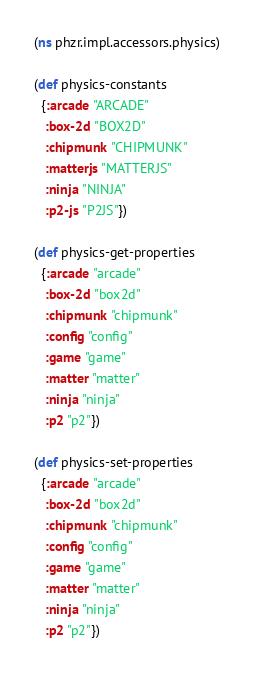Convert code to text. <code><loc_0><loc_0><loc_500><loc_500><_Clojure_>(ns phzr.impl.accessors.physics)

(def physics-constants
  {:arcade "ARCADE"
   :box-2d "BOX2D"
   :chipmunk "CHIPMUNK"
   :matterjs "MATTERJS"
   :ninja "NINJA"
   :p2-js "P2JS"})

(def physics-get-properties
  {:arcade "arcade"
   :box-2d "box2d"
   :chipmunk "chipmunk"
   :config "config"
   :game "game"
   :matter "matter"
   :ninja "ninja"
   :p2 "p2"})

(def physics-set-properties
  {:arcade "arcade"
   :box-2d "box2d"
   :chipmunk "chipmunk"
   :config "config"
   :game "game"
   :matter "matter"
   :ninja "ninja"
   :p2 "p2"})</code> 